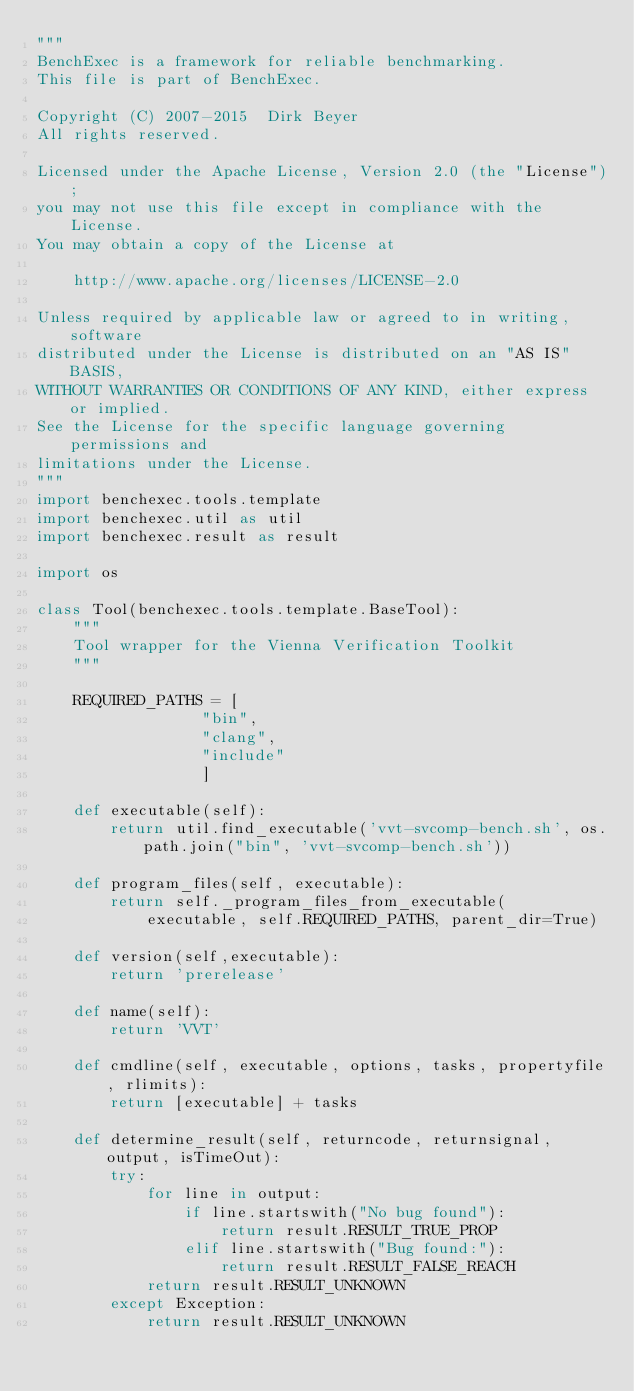Convert code to text. <code><loc_0><loc_0><loc_500><loc_500><_Python_>"""
BenchExec is a framework for reliable benchmarking.
This file is part of BenchExec.

Copyright (C) 2007-2015  Dirk Beyer
All rights reserved.

Licensed under the Apache License, Version 2.0 (the "License");
you may not use this file except in compliance with the License.
You may obtain a copy of the License at

    http://www.apache.org/licenses/LICENSE-2.0

Unless required by applicable law or agreed to in writing, software
distributed under the License is distributed on an "AS IS" BASIS,
WITHOUT WARRANTIES OR CONDITIONS OF ANY KIND, either express or implied.
See the License for the specific language governing permissions and
limitations under the License.
"""
import benchexec.tools.template
import benchexec.util as util
import benchexec.result as result

import os

class Tool(benchexec.tools.template.BaseTool):
    """
    Tool wrapper for the Vienna Verification Toolkit
    """

    REQUIRED_PATHS = [
                  "bin",
                  "clang",
                  "include"
                  ]

    def executable(self):
        return util.find_executable('vvt-svcomp-bench.sh', os.path.join("bin", 'vvt-svcomp-bench.sh'))

    def program_files(self, executable):
        return self._program_files_from_executable(
            executable, self.REQUIRED_PATHS, parent_dir=True)

    def version(self,executable):
        return 'prerelease'

    def name(self):
        return 'VVT'

    def cmdline(self, executable, options, tasks, propertyfile, rlimits):
        return [executable] + tasks

    def determine_result(self, returncode, returnsignal, output, isTimeOut):
        try:
            for line in output:
                if line.startswith("No bug found"):
                    return result.RESULT_TRUE_PROP
                elif line.startswith("Bug found:"):
                    return result.RESULT_FALSE_REACH
            return result.RESULT_UNKNOWN
        except Exception:
            return result.RESULT_UNKNOWN
</code> 